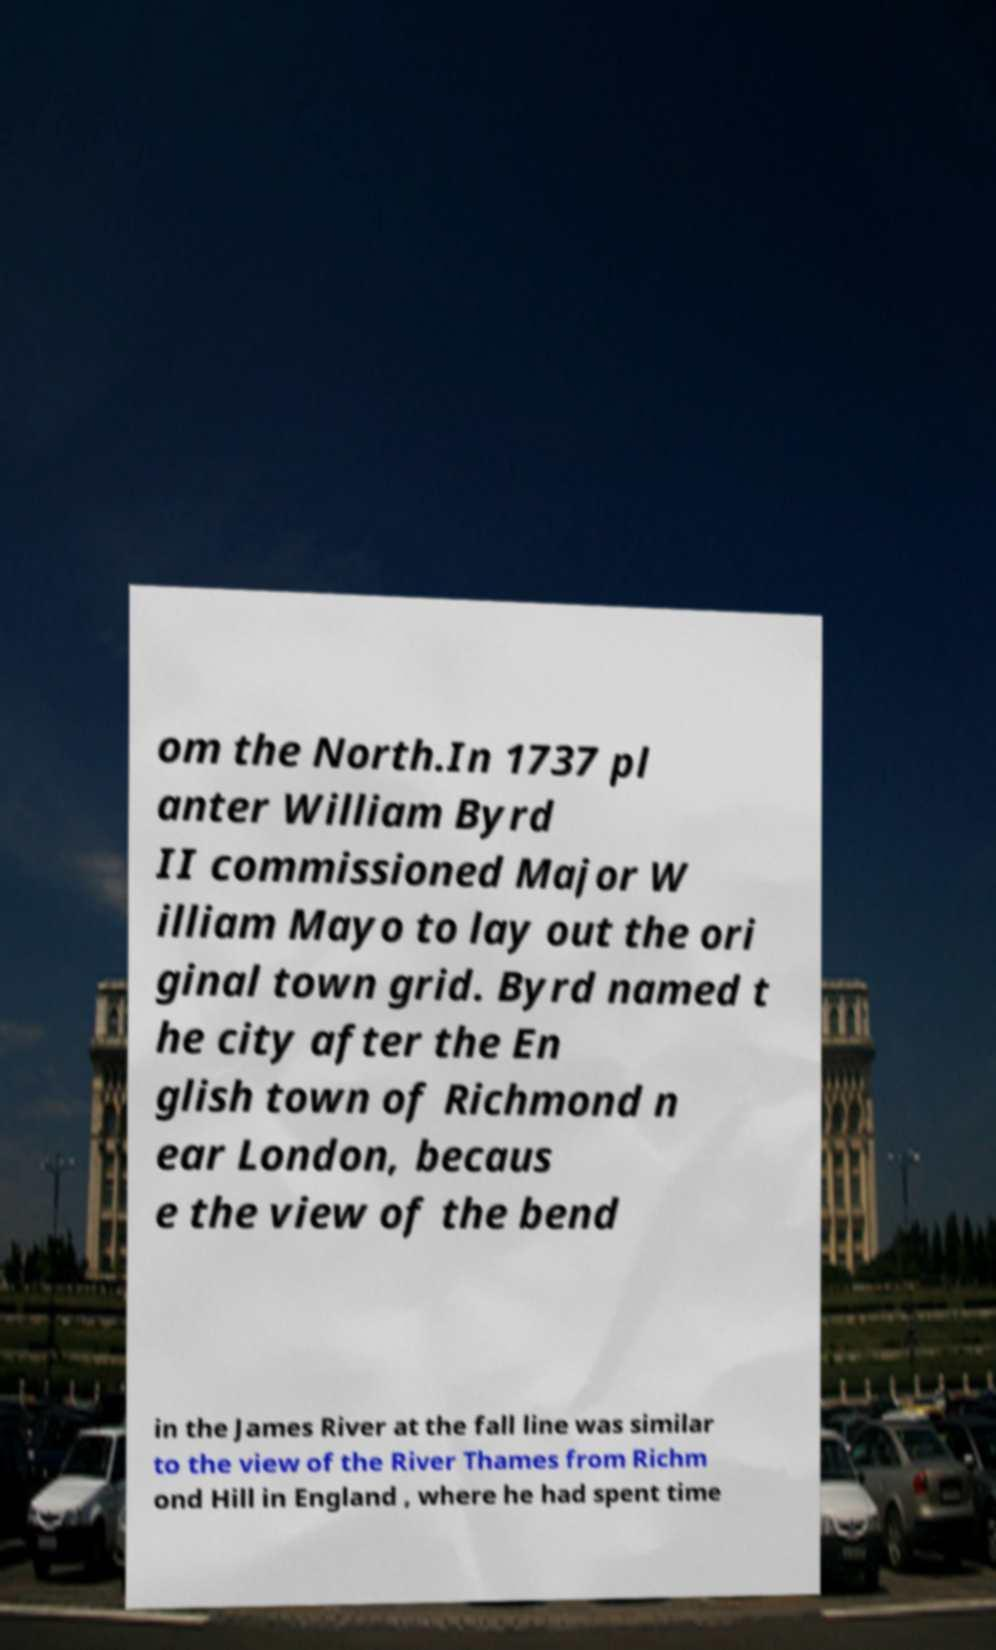Please read and relay the text visible in this image. What does it say? om the North.In 1737 pl anter William Byrd II commissioned Major W illiam Mayo to lay out the ori ginal town grid. Byrd named t he city after the En glish town of Richmond n ear London, becaus e the view of the bend in the James River at the fall line was similar to the view of the River Thames from Richm ond Hill in England , where he had spent time 